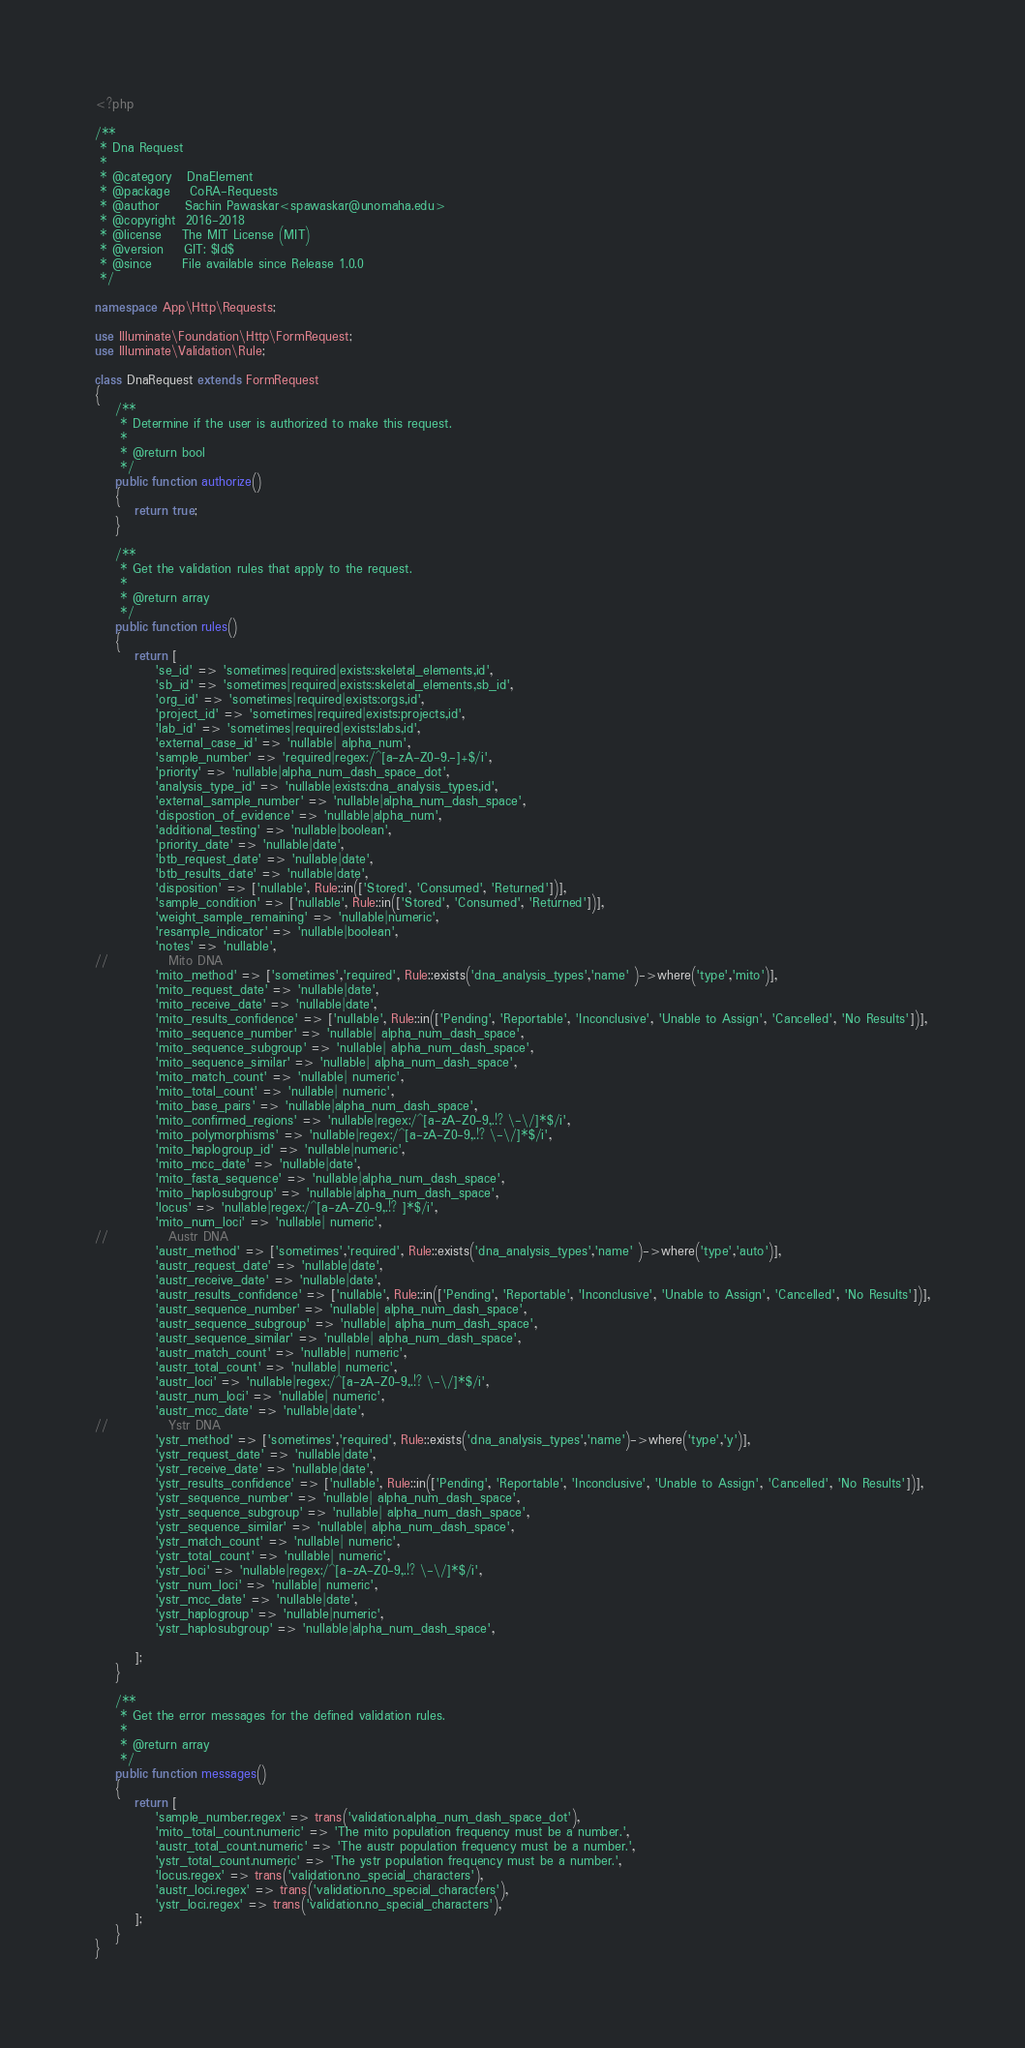Convert code to text. <code><loc_0><loc_0><loc_500><loc_500><_PHP_><?php

/**
 * Dna Request
 *
 * @category   DnaElement
 * @package    CoRA-Requests
 * @author     Sachin Pawaskar<spawaskar@unomaha.edu>
 * @copyright  2016-2018
 * @license    The MIT License (MIT)
 * @version    GIT: $Id$
 * @since      File available since Release 1.0.0
 */

namespace App\Http\Requests;

use Illuminate\Foundation\Http\FormRequest;
use Illuminate\Validation\Rule;

class DnaRequest extends FormRequest
{
    /**
     * Determine if the user is authorized to make this request.
     *
     * @return bool
     */
    public function authorize()
    {
        return true;
    }

    /**
     * Get the validation rules that apply to the request.
     *
     * @return array
     */
    public function rules()
    {
        return [
            'se_id' => 'sometimes|required|exists:skeletal_elements,id',
            'sb_id' => 'sometimes|required|exists:skeletal_elements,sb_id',
            'org_id' => 'sometimes|required|exists:orgs,id',
            'project_id' => 'sometimes|required|exists:projects,id',
            'lab_id' => 'sometimes|required|exists:labs,id',
            'external_case_id' => 'nullable| alpha_num',
            'sample_number' => 'required|regex:/^[a-zA-Z0-9.-]+$/i',
            'priority' => 'nullable|alpha_num_dash_space_dot',
            'analysis_type_id' => 'nullable|exists:dna_analysis_types,id',
            'external_sample_number' => 'nullable|alpha_num_dash_space',
            'dispostion_of_evidence' => 'nullable|alpha_num',
            'additional_testing' => 'nullable|boolean',
            'priority_date' => 'nullable|date',
            'btb_request_date' => 'nullable|date',
            'btb_results_date' => 'nullable|date',
            'disposition' => ['nullable', Rule::in(['Stored', 'Consumed', 'Returned'])],
            'sample_condition' => ['nullable', Rule::in(['Stored', 'Consumed', 'Returned'])],
            'weight_sample_remaining' => 'nullable|numeric',
            'resample_indicator' => 'nullable|boolean',
            'notes' => 'nullable',
//            Mito DNA
            'mito_method' => ['sometimes','required', Rule::exists('dna_analysis_types','name' )->where('type','mito')],
            'mito_request_date' => 'nullable|date',
            'mito_receive_date' => 'nullable|date',
            'mito_results_confidence' => ['nullable', Rule::in(['Pending', 'Reportable', 'Inconclusive', 'Unable to Assign', 'Cancelled', 'No Results'])],
            'mito_sequence_number' => 'nullable| alpha_num_dash_space',
            'mito_sequence_subgroup' => 'nullable| alpha_num_dash_space',
            'mito_sequence_similar' => 'nullable| alpha_num_dash_space',
            'mito_match_count' => 'nullable| numeric',
            'mito_total_count' => 'nullable| numeric',
            'mito_base_pairs' => 'nullable|alpha_num_dash_space',
            'mito_confirmed_regions' => 'nullable|regex:/^[a-zA-Z0-9,.!? \-\/]*$/i',
            'mito_polymorphisms' => 'nullable|regex:/^[a-zA-Z0-9,.!? \-\/]*$/i',
            'mito_haplogroup_id' => 'nullable|numeric',
            'mito_mcc_date' => 'nullable|date',
            'mito_fasta_sequence' => 'nullable|alpha_num_dash_space',
            'mito_haplosubgroup' => 'nullable|alpha_num_dash_space',
            'locus' => 'nullable|regex:/^[a-zA-Z0-9,.!? ]*$/i',
            'mito_num_loci' => 'nullable| numeric',
//            Austr DNA
            'austr_method' => ['sometimes','required', Rule::exists('dna_analysis_types','name' )->where('type','auto')],
            'austr_request_date' => 'nullable|date',
            'austr_receive_date' => 'nullable|date',
            'austr_results_confidence' => ['nullable', Rule::in(['Pending', 'Reportable', 'Inconclusive', 'Unable to Assign', 'Cancelled', 'No Results'])],
            'austr_sequence_number' => 'nullable| alpha_num_dash_space',
            'austr_sequence_subgroup' => 'nullable| alpha_num_dash_space',
            'austr_sequence_similar' => 'nullable| alpha_num_dash_space',
            'austr_match_count' => 'nullable| numeric',
            'austr_total_count' => 'nullable| numeric',
            'austr_loci' => 'nullable|regex:/^[a-zA-Z0-9,.!? \-\/]*$/i',
            'austr_num_loci' => 'nullable| numeric',
            'austr_mcc_date' => 'nullable|date',
//            Ystr DNA
            'ystr_method' => ['sometimes','required', Rule::exists('dna_analysis_types','name')->where('type','y')],
            'ystr_request_date' => 'nullable|date',
            'ystr_receive_date' => 'nullable|date',
            'ystr_results_confidence' => ['nullable', Rule::in(['Pending', 'Reportable', 'Inconclusive', 'Unable to Assign', 'Cancelled', 'No Results'])],
            'ystr_sequence_number' => 'nullable| alpha_num_dash_space',
            'ystr_sequence_subgroup' => 'nullable| alpha_num_dash_space',
            'ystr_sequence_similar' => 'nullable| alpha_num_dash_space',
            'ystr_match_count' => 'nullable| numeric',
            'ystr_total_count' => 'nullable| numeric',
            'ystr_loci' => 'nullable|regex:/^[a-zA-Z0-9,.!? \-\/]*$/i',
            'ystr_num_loci' => 'nullable| numeric',
            'ystr_mcc_date' => 'nullable|date',
            'ystr_haplogroup' => 'nullable|numeric',
            'ystr_haplosubgroup' => 'nullable|alpha_num_dash_space',

        ];
    }

    /**
     * Get the error messages for the defined validation rules.
     *
     * @return array
     */
    public function messages()
    {
        return [
            'sample_number.regex' => trans('validation.alpha_num_dash_space_dot'),
            'mito_total_count.numeric' => 'The mito population frequency must be a number.',
            'austr_total_count.numeric' => 'The austr population frequency must be a number.',
            'ystr_total_count.numeric' => 'The ystr population frequency must be a number.',
            'locus.regex' => trans('validation.no_special_characters'),
            'austr_loci.regex' => trans('validation.no_special_characters'),
            'ystr_loci.regex' => trans('validation.no_special_characters'),
        ];
    }
}
</code> 